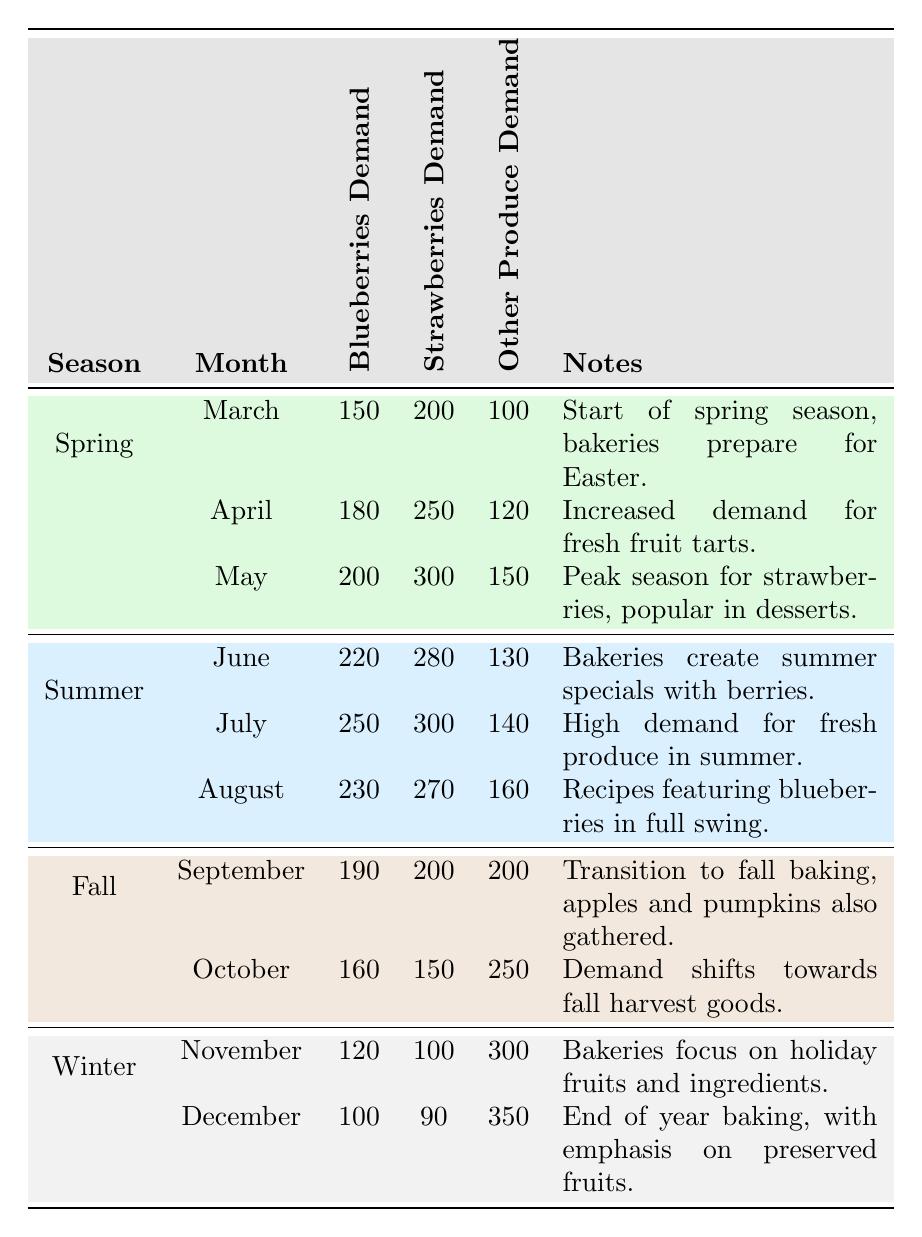What is the demand for blueberries in May? The table lists the demand for blueberries under the month of May, which shows a demand of 200 units.
Answer: 200 What season has the highest strawberries demand in the table? By examining the seasonal demands for strawberries month by month, the highest demand occurs in May with 300 units.
Answer: Spring What is the total demand for other produce in the summer months? The total demand for other produce during summer can be calculated by adding the demands for each month: June (130) + July (140) + August (160) = 430.
Answer: 430 Is the demand for strawberries higher in July than in October? By comparing the demands, strawberries demand in July is 300 while in October it is 150. Since 300 is greater than 150, the statement is true.
Answer: Yes What is the average demand for blueberries across all fall months? The demands for blueberries are 190 in September and 160 in October. To find the average: (190 + 160) / 2 = 175.
Answer: 175 What month has the lowest demand for other produce, and what is that demand? The table shows that the lowest demand for other produce is in December with a demand of 350 units.
Answer: December, 350 In which month does the demand for strawberries rise above 250? The months in the table where strawberries demand exceeds 250 are April (250) and May (300). Thus, demand rises above 250 starting from May.
Answer: May Calculate the difference in blueberries demand between July and November. The blueberries demand in July is 250 and in November it is 120. The difference is 250 - 120 = 130.
Answer: 130 Is the demand for blueberries consistent throughout the year? Analyzing the data across all months, the demand varies significantly, decreasing in fall and winter compared to spring and summer, indicating inconsistency.
Answer: No 